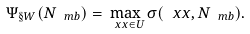<formula> <loc_0><loc_0><loc_500><loc_500>\Psi _ { \S W } ( N _ { \ m b } ) = \max _ { \ x x \in U } \sigma ( \ x x , N _ { \ m b } ) .</formula> 